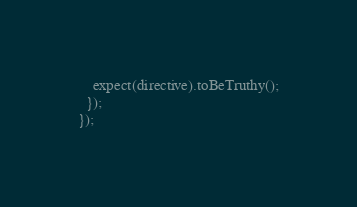Convert code to text. <code><loc_0><loc_0><loc_500><loc_500><_TypeScript_>    expect(directive).toBeTruthy();
  });
});
</code> 